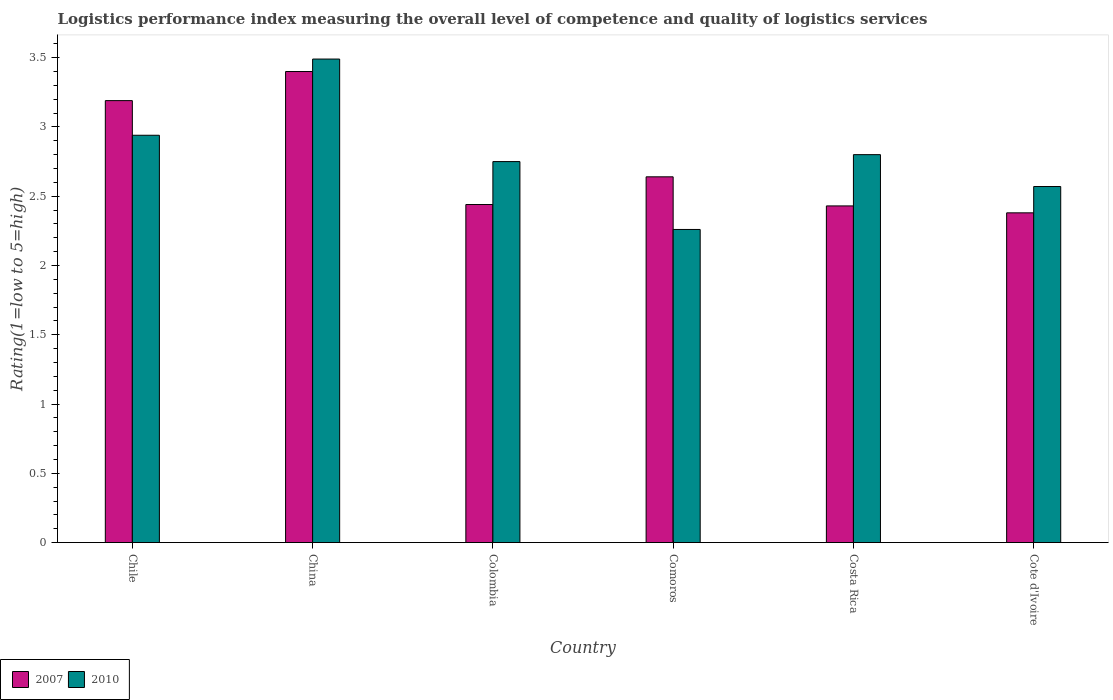How many different coloured bars are there?
Your answer should be compact. 2. Are the number of bars per tick equal to the number of legend labels?
Your answer should be very brief. Yes. How many bars are there on the 6th tick from the left?
Keep it short and to the point. 2. How many bars are there on the 3rd tick from the right?
Ensure brevity in your answer.  2. In how many cases, is the number of bars for a given country not equal to the number of legend labels?
Offer a very short reply. 0. What is the Logistic performance index in 2007 in Cote d'Ivoire?
Your answer should be compact. 2.38. Across all countries, what is the maximum Logistic performance index in 2010?
Provide a short and direct response. 3.49. Across all countries, what is the minimum Logistic performance index in 2007?
Your answer should be compact. 2.38. In which country was the Logistic performance index in 2010 maximum?
Your response must be concise. China. In which country was the Logistic performance index in 2007 minimum?
Your answer should be very brief. Cote d'Ivoire. What is the total Logistic performance index in 2007 in the graph?
Provide a succinct answer. 16.48. What is the difference between the Logistic performance index in 2007 in Chile and that in Cote d'Ivoire?
Ensure brevity in your answer.  0.81. What is the difference between the Logistic performance index in 2007 in Chile and the Logistic performance index in 2010 in Costa Rica?
Provide a succinct answer. 0.39. What is the average Logistic performance index in 2010 per country?
Give a very brief answer. 2.8. What is the difference between the Logistic performance index of/in 2010 and Logistic performance index of/in 2007 in Comoros?
Your answer should be compact. -0.38. What is the ratio of the Logistic performance index in 2007 in Chile to that in Costa Rica?
Offer a very short reply. 1.31. Is the difference between the Logistic performance index in 2010 in Comoros and Costa Rica greater than the difference between the Logistic performance index in 2007 in Comoros and Costa Rica?
Ensure brevity in your answer.  No. What is the difference between the highest and the second highest Logistic performance index in 2007?
Your response must be concise. 0.55. What is the difference between the highest and the lowest Logistic performance index in 2007?
Keep it short and to the point. 1.02. What does the 1st bar from the left in Costa Rica represents?
Your answer should be very brief. 2007. What does the 1st bar from the right in Comoros represents?
Keep it short and to the point. 2010. How many bars are there?
Offer a very short reply. 12. Are all the bars in the graph horizontal?
Ensure brevity in your answer.  No. How many legend labels are there?
Your answer should be very brief. 2. How are the legend labels stacked?
Make the answer very short. Horizontal. What is the title of the graph?
Your answer should be very brief. Logistics performance index measuring the overall level of competence and quality of logistics services. Does "1995" appear as one of the legend labels in the graph?
Offer a very short reply. No. What is the label or title of the Y-axis?
Offer a very short reply. Rating(1=low to 5=high). What is the Rating(1=low to 5=high) of 2007 in Chile?
Ensure brevity in your answer.  3.19. What is the Rating(1=low to 5=high) of 2010 in Chile?
Your response must be concise. 2.94. What is the Rating(1=low to 5=high) of 2007 in China?
Your response must be concise. 3.4. What is the Rating(1=low to 5=high) of 2010 in China?
Give a very brief answer. 3.49. What is the Rating(1=low to 5=high) of 2007 in Colombia?
Your answer should be compact. 2.44. What is the Rating(1=low to 5=high) in 2010 in Colombia?
Keep it short and to the point. 2.75. What is the Rating(1=low to 5=high) in 2007 in Comoros?
Provide a short and direct response. 2.64. What is the Rating(1=low to 5=high) of 2010 in Comoros?
Give a very brief answer. 2.26. What is the Rating(1=low to 5=high) in 2007 in Costa Rica?
Keep it short and to the point. 2.43. What is the Rating(1=low to 5=high) in 2010 in Costa Rica?
Provide a short and direct response. 2.8. What is the Rating(1=low to 5=high) in 2007 in Cote d'Ivoire?
Your answer should be compact. 2.38. What is the Rating(1=low to 5=high) of 2010 in Cote d'Ivoire?
Make the answer very short. 2.57. Across all countries, what is the maximum Rating(1=low to 5=high) of 2010?
Make the answer very short. 3.49. Across all countries, what is the minimum Rating(1=low to 5=high) in 2007?
Your answer should be very brief. 2.38. Across all countries, what is the minimum Rating(1=low to 5=high) of 2010?
Give a very brief answer. 2.26. What is the total Rating(1=low to 5=high) in 2007 in the graph?
Your response must be concise. 16.48. What is the total Rating(1=low to 5=high) in 2010 in the graph?
Your response must be concise. 16.81. What is the difference between the Rating(1=low to 5=high) of 2007 in Chile and that in China?
Your answer should be very brief. -0.21. What is the difference between the Rating(1=low to 5=high) in 2010 in Chile and that in China?
Your answer should be compact. -0.55. What is the difference between the Rating(1=low to 5=high) in 2010 in Chile and that in Colombia?
Provide a short and direct response. 0.19. What is the difference between the Rating(1=low to 5=high) in 2007 in Chile and that in Comoros?
Your answer should be very brief. 0.55. What is the difference between the Rating(1=low to 5=high) in 2010 in Chile and that in Comoros?
Provide a short and direct response. 0.68. What is the difference between the Rating(1=low to 5=high) in 2007 in Chile and that in Costa Rica?
Keep it short and to the point. 0.76. What is the difference between the Rating(1=low to 5=high) in 2010 in Chile and that in Costa Rica?
Make the answer very short. 0.14. What is the difference between the Rating(1=low to 5=high) of 2007 in Chile and that in Cote d'Ivoire?
Make the answer very short. 0.81. What is the difference between the Rating(1=low to 5=high) in 2010 in Chile and that in Cote d'Ivoire?
Your answer should be very brief. 0.37. What is the difference between the Rating(1=low to 5=high) in 2007 in China and that in Colombia?
Provide a short and direct response. 0.96. What is the difference between the Rating(1=low to 5=high) in 2010 in China and that in Colombia?
Offer a very short reply. 0.74. What is the difference between the Rating(1=low to 5=high) of 2007 in China and that in Comoros?
Your answer should be very brief. 0.76. What is the difference between the Rating(1=low to 5=high) of 2010 in China and that in Comoros?
Offer a very short reply. 1.23. What is the difference between the Rating(1=low to 5=high) in 2007 in China and that in Costa Rica?
Ensure brevity in your answer.  0.97. What is the difference between the Rating(1=low to 5=high) of 2010 in China and that in Costa Rica?
Provide a succinct answer. 0.69. What is the difference between the Rating(1=low to 5=high) of 2007 in China and that in Cote d'Ivoire?
Provide a succinct answer. 1.02. What is the difference between the Rating(1=low to 5=high) in 2007 in Colombia and that in Comoros?
Your answer should be compact. -0.2. What is the difference between the Rating(1=low to 5=high) in 2010 in Colombia and that in Comoros?
Give a very brief answer. 0.49. What is the difference between the Rating(1=low to 5=high) in 2007 in Colombia and that in Cote d'Ivoire?
Make the answer very short. 0.06. What is the difference between the Rating(1=low to 5=high) of 2010 in Colombia and that in Cote d'Ivoire?
Provide a succinct answer. 0.18. What is the difference between the Rating(1=low to 5=high) of 2007 in Comoros and that in Costa Rica?
Provide a short and direct response. 0.21. What is the difference between the Rating(1=low to 5=high) in 2010 in Comoros and that in Costa Rica?
Your answer should be compact. -0.54. What is the difference between the Rating(1=low to 5=high) of 2007 in Comoros and that in Cote d'Ivoire?
Provide a succinct answer. 0.26. What is the difference between the Rating(1=low to 5=high) in 2010 in Comoros and that in Cote d'Ivoire?
Give a very brief answer. -0.31. What is the difference between the Rating(1=low to 5=high) in 2007 in Costa Rica and that in Cote d'Ivoire?
Give a very brief answer. 0.05. What is the difference between the Rating(1=low to 5=high) of 2010 in Costa Rica and that in Cote d'Ivoire?
Provide a short and direct response. 0.23. What is the difference between the Rating(1=low to 5=high) in 2007 in Chile and the Rating(1=low to 5=high) in 2010 in Colombia?
Give a very brief answer. 0.44. What is the difference between the Rating(1=low to 5=high) of 2007 in Chile and the Rating(1=low to 5=high) of 2010 in Costa Rica?
Your response must be concise. 0.39. What is the difference between the Rating(1=low to 5=high) of 2007 in Chile and the Rating(1=low to 5=high) of 2010 in Cote d'Ivoire?
Give a very brief answer. 0.62. What is the difference between the Rating(1=low to 5=high) of 2007 in China and the Rating(1=low to 5=high) of 2010 in Colombia?
Keep it short and to the point. 0.65. What is the difference between the Rating(1=low to 5=high) of 2007 in China and the Rating(1=low to 5=high) of 2010 in Comoros?
Offer a terse response. 1.14. What is the difference between the Rating(1=low to 5=high) of 2007 in China and the Rating(1=low to 5=high) of 2010 in Costa Rica?
Your answer should be compact. 0.6. What is the difference between the Rating(1=low to 5=high) in 2007 in China and the Rating(1=low to 5=high) in 2010 in Cote d'Ivoire?
Make the answer very short. 0.83. What is the difference between the Rating(1=low to 5=high) of 2007 in Colombia and the Rating(1=low to 5=high) of 2010 in Comoros?
Your answer should be compact. 0.18. What is the difference between the Rating(1=low to 5=high) in 2007 in Colombia and the Rating(1=low to 5=high) in 2010 in Costa Rica?
Offer a very short reply. -0.36. What is the difference between the Rating(1=low to 5=high) in 2007 in Colombia and the Rating(1=low to 5=high) in 2010 in Cote d'Ivoire?
Make the answer very short. -0.13. What is the difference between the Rating(1=low to 5=high) in 2007 in Comoros and the Rating(1=low to 5=high) in 2010 in Costa Rica?
Offer a terse response. -0.16. What is the difference between the Rating(1=low to 5=high) in 2007 in Comoros and the Rating(1=low to 5=high) in 2010 in Cote d'Ivoire?
Your answer should be very brief. 0.07. What is the difference between the Rating(1=low to 5=high) of 2007 in Costa Rica and the Rating(1=low to 5=high) of 2010 in Cote d'Ivoire?
Offer a very short reply. -0.14. What is the average Rating(1=low to 5=high) in 2007 per country?
Provide a short and direct response. 2.75. What is the average Rating(1=low to 5=high) in 2010 per country?
Your answer should be compact. 2.8. What is the difference between the Rating(1=low to 5=high) of 2007 and Rating(1=low to 5=high) of 2010 in Chile?
Give a very brief answer. 0.25. What is the difference between the Rating(1=low to 5=high) of 2007 and Rating(1=low to 5=high) of 2010 in China?
Your answer should be very brief. -0.09. What is the difference between the Rating(1=low to 5=high) of 2007 and Rating(1=low to 5=high) of 2010 in Colombia?
Keep it short and to the point. -0.31. What is the difference between the Rating(1=low to 5=high) of 2007 and Rating(1=low to 5=high) of 2010 in Comoros?
Your answer should be compact. 0.38. What is the difference between the Rating(1=low to 5=high) of 2007 and Rating(1=low to 5=high) of 2010 in Costa Rica?
Your answer should be very brief. -0.37. What is the difference between the Rating(1=low to 5=high) in 2007 and Rating(1=low to 5=high) in 2010 in Cote d'Ivoire?
Your response must be concise. -0.19. What is the ratio of the Rating(1=low to 5=high) in 2007 in Chile to that in China?
Your answer should be compact. 0.94. What is the ratio of the Rating(1=low to 5=high) in 2010 in Chile to that in China?
Your answer should be compact. 0.84. What is the ratio of the Rating(1=low to 5=high) of 2007 in Chile to that in Colombia?
Ensure brevity in your answer.  1.31. What is the ratio of the Rating(1=low to 5=high) of 2010 in Chile to that in Colombia?
Keep it short and to the point. 1.07. What is the ratio of the Rating(1=low to 5=high) in 2007 in Chile to that in Comoros?
Make the answer very short. 1.21. What is the ratio of the Rating(1=low to 5=high) of 2010 in Chile to that in Comoros?
Keep it short and to the point. 1.3. What is the ratio of the Rating(1=low to 5=high) of 2007 in Chile to that in Costa Rica?
Give a very brief answer. 1.31. What is the ratio of the Rating(1=low to 5=high) in 2007 in Chile to that in Cote d'Ivoire?
Your answer should be very brief. 1.34. What is the ratio of the Rating(1=low to 5=high) in 2010 in Chile to that in Cote d'Ivoire?
Give a very brief answer. 1.14. What is the ratio of the Rating(1=low to 5=high) in 2007 in China to that in Colombia?
Keep it short and to the point. 1.39. What is the ratio of the Rating(1=low to 5=high) of 2010 in China to that in Colombia?
Your response must be concise. 1.27. What is the ratio of the Rating(1=low to 5=high) of 2007 in China to that in Comoros?
Provide a short and direct response. 1.29. What is the ratio of the Rating(1=low to 5=high) in 2010 in China to that in Comoros?
Give a very brief answer. 1.54. What is the ratio of the Rating(1=low to 5=high) in 2007 in China to that in Costa Rica?
Your response must be concise. 1.4. What is the ratio of the Rating(1=low to 5=high) of 2010 in China to that in Costa Rica?
Make the answer very short. 1.25. What is the ratio of the Rating(1=low to 5=high) in 2007 in China to that in Cote d'Ivoire?
Ensure brevity in your answer.  1.43. What is the ratio of the Rating(1=low to 5=high) in 2010 in China to that in Cote d'Ivoire?
Make the answer very short. 1.36. What is the ratio of the Rating(1=low to 5=high) in 2007 in Colombia to that in Comoros?
Provide a short and direct response. 0.92. What is the ratio of the Rating(1=low to 5=high) of 2010 in Colombia to that in Comoros?
Make the answer very short. 1.22. What is the ratio of the Rating(1=low to 5=high) in 2007 in Colombia to that in Costa Rica?
Provide a short and direct response. 1. What is the ratio of the Rating(1=low to 5=high) of 2010 in Colombia to that in Costa Rica?
Provide a short and direct response. 0.98. What is the ratio of the Rating(1=low to 5=high) in 2007 in Colombia to that in Cote d'Ivoire?
Your answer should be very brief. 1.03. What is the ratio of the Rating(1=low to 5=high) in 2010 in Colombia to that in Cote d'Ivoire?
Your answer should be very brief. 1.07. What is the ratio of the Rating(1=low to 5=high) of 2007 in Comoros to that in Costa Rica?
Provide a succinct answer. 1.09. What is the ratio of the Rating(1=low to 5=high) of 2010 in Comoros to that in Costa Rica?
Offer a very short reply. 0.81. What is the ratio of the Rating(1=low to 5=high) in 2007 in Comoros to that in Cote d'Ivoire?
Keep it short and to the point. 1.11. What is the ratio of the Rating(1=low to 5=high) in 2010 in Comoros to that in Cote d'Ivoire?
Ensure brevity in your answer.  0.88. What is the ratio of the Rating(1=low to 5=high) of 2010 in Costa Rica to that in Cote d'Ivoire?
Your answer should be very brief. 1.09. What is the difference between the highest and the second highest Rating(1=low to 5=high) of 2007?
Offer a very short reply. 0.21. What is the difference between the highest and the second highest Rating(1=low to 5=high) of 2010?
Your response must be concise. 0.55. What is the difference between the highest and the lowest Rating(1=low to 5=high) in 2010?
Your answer should be very brief. 1.23. 